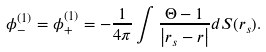<formula> <loc_0><loc_0><loc_500><loc_500>\phi _ { - } ^ { ( 1 ) } = \phi _ { + } ^ { ( 1 ) } = - \frac { 1 } { 4 \pi } \int \frac { \Theta - 1 } { \left | r _ { s } - r \right | } d S ( r _ { s } ) .</formula> 